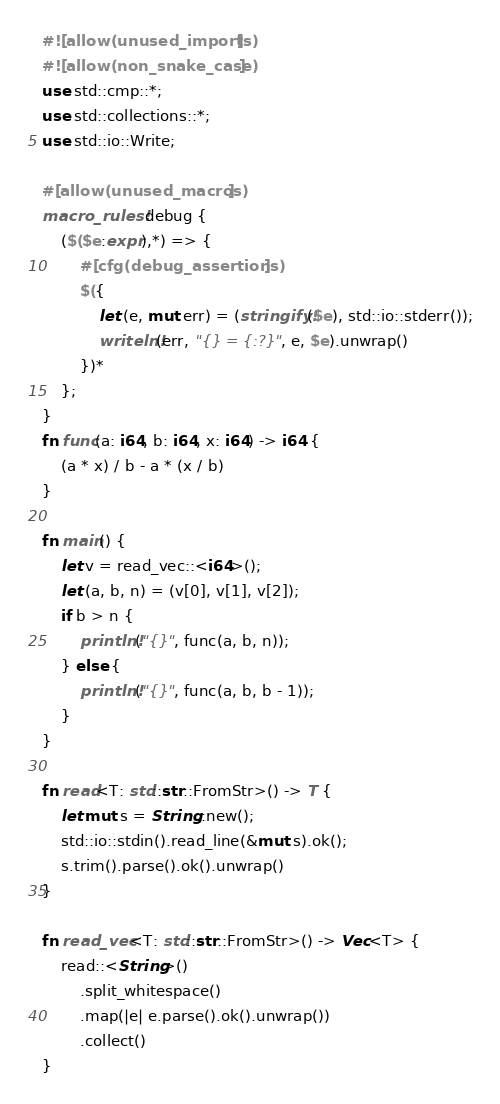<code> <loc_0><loc_0><loc_500><loc_500><_Rust_>#![allow(unused_imports)]
#![allow(non_snake_case)]
use std::cmp::*;
use std::collections::*;
use std::io::Write;

#[allow(unused_macros)]
macro_rules! debug {
    ($($e:expr),*) => {
        #[cfg(debug_assertions)]
        $({
            let (e, mut err) = (stringify!($e), std::io::stderr());
            writeln!(err, "{} = {:?}", e, $e).unwrap()
        })*
    };
}
fn func(a: i64, b: i64, x: i64) -> i64 {
    (a * x) / b - a * (x / b)
}

fn main() {
    let v = read_vec::<i64>();
    let (a, b, n) = (v[0], v[1], v[2]);
    if b > n {
        println!("{}", func(a, b, n));
    } else {
        println!("{}", func(a, b, b - 1));
    }
}

fn read<T: std::str::FromStr>() -> T {
    let mut s = String::new();
    std::io::stdin().read_line(&mut s).ok();
    s.trim().parse().ok().unwrap()
}

fn read_vec<T: std::str::FromStr>() -> Vec<T> {
    read::<String>()
        .split_whitespace()
        .map(|e| e.parse().ok().unwrap())
        .collect()
}
</code> 